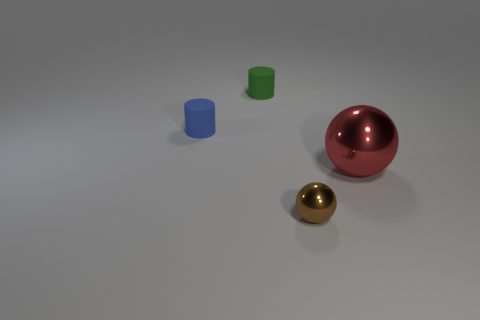There is a tiny shiny thing; is it the same shape as the thing to the right of the small brown metal thing?
Your answer should be very brief. Yes. The blue rubber object left of the sphere that is to the left of the metal sphere that is behind the brown object is what shape?
Keep it short and to the point. Cylinder. What number of other objects are the same material as the small green cylinder?
Your answer should be compact. 1. How many things are tiny matte objects right of the small blue rubber cylinder or large yellow matte blocks?
Give a very brief answer. 1. What shape is the tiny matte object that is to the right of the tiny matte cylinder that is left of the green object?
Offer a very short reply. Cylinder. There is a big red shiny object that is in front of the green cylinder; does it have the same shape as the brown metallic thing?
Provide a short and direct response. Yes. The cylinder that is behind the small blue thing is what color?
Your answer should be very brief. Green. How many cubes are either big red rubber objects or big red shiny objects?
Give a very brief answer. 0. There is a metallic sphere that is to the left of the metallic object right of the small brown thing; what is its size?
Offer a very short reply. Small. There is a red shiny sphere; how many small objects are behind it?
Make the answer very short. 2. 